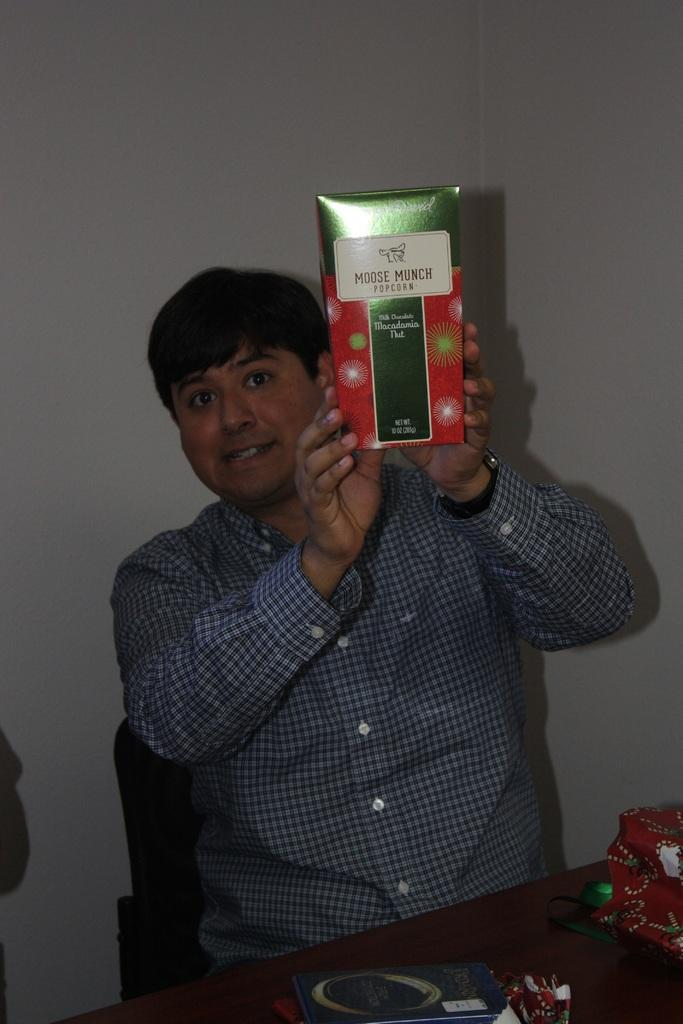<image>
Render a clear and concise summary of the photo. a man holding up a box of Moose Munch 